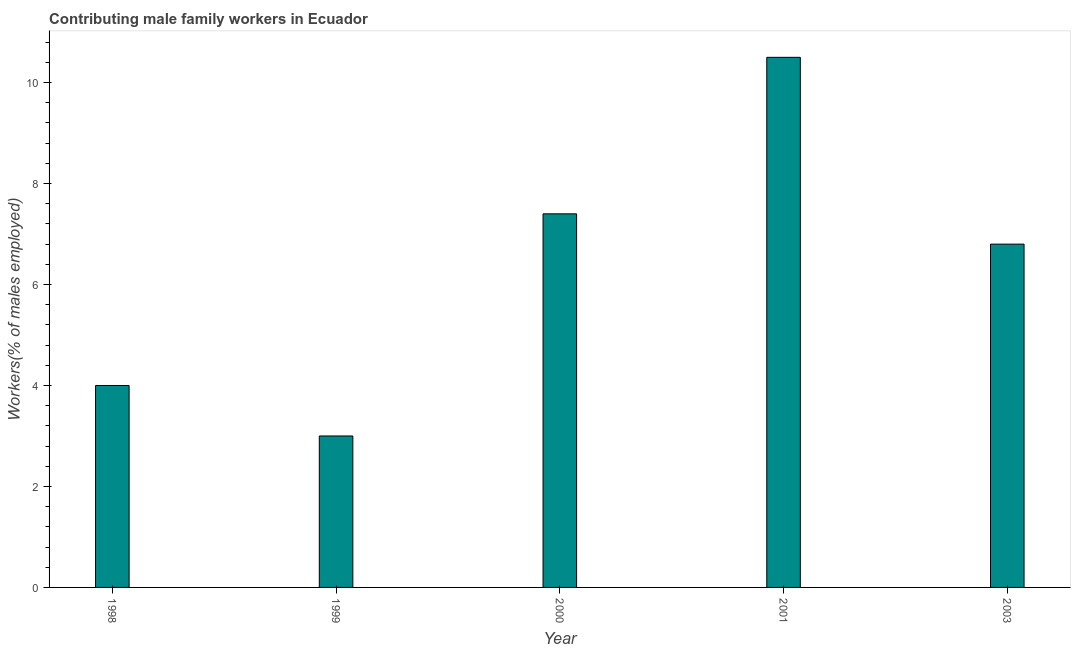What is the title of the graph?
Ensure brevity in your answer.  Contributing male family workers in Ecuador. What is the label or title of the X-axis?
Offer a terse response. Year. What is the label or title of the Y-axis?
Your answer should be very brief. Workers(% of males employed). Across all years, what is the maximum contributing male family workers?
Keep it short and to the point. 10.5. Across all years, what is the minimum contributing male family workers?
Give a very brief answer. 3. In which year was the contributing male family workers maximum?
Your answer should be compact. 2001. What is the sum of the contributing male family workers?
Your answer should be very brief. 31.7. What is the difference between the contributing male family workers in 2001 and 2003?
Provide a short and direct response. 3.7. What is the average contributing male family workers per year?
Give a very brief answer. 6.34. What is the median contributing male family workers?
Keep it short and to the point. 6.8. In how many years, is the contributing male family workers greater than 6 %?
Your answer should be very brief. 3. What is the ratio of the contributing male family workers in 1998 to that in 1999?
Your response must be concise. 1.33. Is the contributing male family workers in 1999 less than that in 2003?
Offer a very short reply. Yes. What is the difference between the highest and the second highest contributing male family workers?
Provide a succinct answer. 3.1. What is the difference between the highest and the lowest contributing male family workers?
Provide a short and direct response. 7.5. In how many years, is the contributing male family workers greater than the average contributing male family workers taken over all years?
Make the answer very short. 3. How many bars are there?
Provide a short and direct response. 5. Are all the bars in the graph horizontal?
Your answer should be very brief. No. What is the difference between two consecutive major ticks on the Y-axis?
Make the answer very short. 2. What is the Workers(% of males employed) of 2000?
Keep it short and to the point. 7.4. What is the Workers(% of males employed) in 2001?
Provide a short and direct response. 10.5. What is the Workers(% of males employed) in 2003?
Keep it short and to the point. 6.8. What is the difference between the Workers(% of males employed) in 1998 and 2000?
Your answer should be very brief. -3.4. What is the difference between the Workers(% of males employed) in 1998 and 2001?
Offer a terse response. -6.5. What is the difference between the Workers(% of males employed) in 2001 and 2003?
Offer a very short reply. 3.7. What is the ratio of the Workers(% of males employed) in 1998 to that in 1999?
Your answer should be very brief. 1.33. What is the ratio of the Workers(% of males employed) in 1998 to that in 2000?
Your response must be concise. 0.54. What is the ratio of the Workers(% of males employed) in 1998 to that in 2001?
Give a very brief answer. 0.38. What is the ratio of the Workers(% of males employed) in 1998 to that in 2003?
Your response must be concise. 0.59. What is the ratio of the Workers(% of males employed) in 1999 to that in 2000?
Ensure brevity in your answer.  0.41. What is the ratio of the Workers(% of males employed) in 1999 to that in 2001?
Keep it short and to the point. 0.29. What is the ratio of the Workers(% of males employed) in 1999 to that in 2003?
Your answer should be compact. 0.44. What is the ratio of the Workers(% of males employed) in 2000 to that in 2001?
Your answer should be compact. 0.7. What is the ratio of the Workers(% of males employed) in 2000 to that in 2003?
Offer a very short reply. 1.09. What is the ratio of the Workers(% of males employed) in 2001 to that in 2003?
Provide a short and direct response. 1.54. 